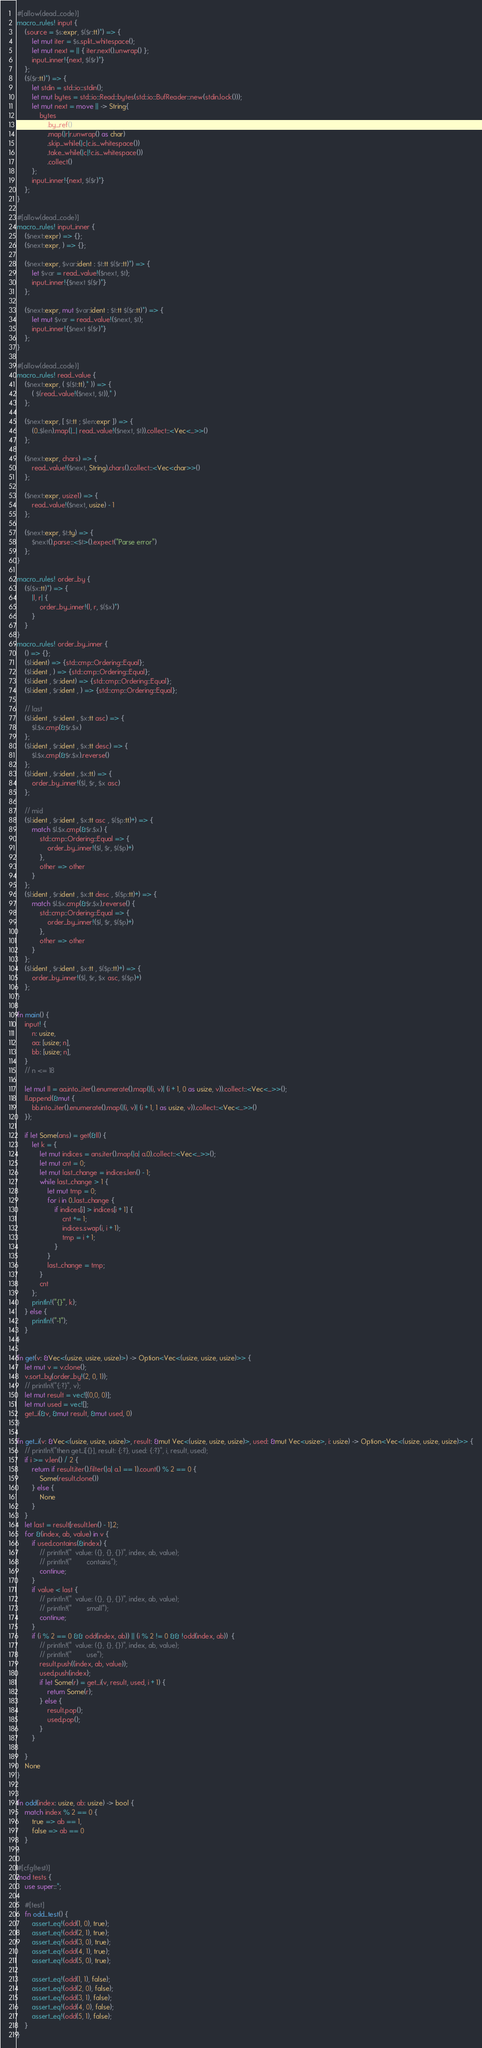Convert code to text. <code><loc_0><loc_0><loc_500><loc_500><_Rust_>#[allow(dead_code)]
macro_rules! input {
    (source = $s:expr, $($r:tt)*) => {
        let mut iter = $s.split_whitespace();
        let mut next = || { iter.next().unwrap() };
        input_inner!{next, $($r)*}
    };
    ($($r:tt)*) => {
        let stdin = std::io::stdin();
        let mut bytes = std::io::Read::bytes(std::io::BufReader::new(stdin.lock()));
        let mut next = move || -> String{
            bytes
                .by_ref()
                .map(|r|r.unwrap() as char)
                .skip_while(|c|c.is_whitespace())
                .take_while(|c|!c.is_whitespace())
                .collect()
        };
        input_inner!{next, $($r)*}
    };
}

#[allow(dead_code)]
macro_rules! input_inner {
    ($next:expr) => {};
    ($next:expr, ) => {};

    ($next:expr, $var:ident : $t:tt $($r:tt)*) => {
        let $var = read_value!($next, $t);
        input_inner!{$next $($r)*}
    };

    ($next:expr, mut $var:ident : $t:tt $($r:tt)*) => {
        let mut $var = read_value!($next, $t);
        input_inner!{$next $($r)*}
    };
}

#[allow(dead_code)]
macro_rules! read_value {
    ($next:expr, ( $($t:tt),* )) => {
        ( $(read_value!($next, $t)),* )
    };

    ($next:expr, [ $t:tt ; $len:expr ]) => {
        (0..$len).map(|_| read_value!($next, $t)).collect::<Vec<_>>()
    };

    ($next:expr, chars) => {
        read_value!($next, String).chars().collect::<Vec<char>>()
    };

    ($next:expr, usize1) => {
        read_value!($next, usize) - 1
    };

    ($next:expr, $t:ty) => {
        $next().parse::<$t>().expect("Parse error")
    };
}

macro_rules! order_by {
    ($($x:tt)*) => {
        |l, r| {
            order_by_inner!(l, r, $($x)*)
        }
    }
}
macro_rules! order_by_inner {
    () => {};
    ($l:ident) => {std::cmp::Ordering::Equal};
    ($l:ident , ) => {std::cmp::Ordering::Equal};
    ($l:ident , $r:ident) => {std::cmp::Ordering::Equal};
    ($l:ident , $r:ident , ) => {std::cmp::Ordering::Equal};

    // last
    ($l:ident , $r:ident , $x:tt asc) => {
        $l.$x.cmp(&$r.$x)
    };
    ($l:ident , $r:ident , $x:tt desc) => {
        $l.$x.cmp(&$r.$x).reverse()
    };
    ($l:ident , $r:ident , $x:tt) => {
        order_by_inner!($l, $r, $x asc)
    };

    // mid
    ($l:ident , $r:ident , $x:tt asc , $($p:tt)+) => {
        match $l.$x.cmp(&$r.$x) {
            std::cmp::Ordering::Equal => {
                order_by_inner!($l, $r, $($p)+)
            },
            other => other
        }
    };
    ($l:ident , $r:ident , $x:tt desc , $($p:tt)+) => {
        match $l.$x.cmp(&$r.$x).reverse() {
            std::cmp::Ordering::Equal => {
                order_by_inner!($l, $r, $($p)+)
            },
            other => other
        }
    };
    ($l:ident , $r:ident , $x:tt , $($p:tt)+) => {
        order_by_inner!($l, $r, $x asc, $($p)+)
    };
}

fn main() {
    input! {
        n: usize,
        aa: [usize; n],
        bb: [usize; n],
    }
    // n <= 18

    let mut ll = aa.into_iter().enumerate().map(|(i, v)| (i + 1, 0 as usize, v)).collect::<Vec<_>>();
    ll.append(&mut {
        bb.into_iter().enumerate().map(|(i, v)| (i + 1, 1 as usize, v)).collect::<Vec<_>>()
    });

    if let Some(ans) = get(&ll) {
        let k = {
            let mut indices = ans.iter().map(|a| a.0).collect::<Vec<_>>();
            let mut cnt = 0;
            let mut last_change = indices.len() - 1;
            while last_change > 1 {
                let mut tmp = 0;
                for i in 0..last_change {
                    if indices[i] > indices[i + 1] {
                        cnt += 1;
                        indices.swap(i, i + 1);
                        tmp = i + 1;
                    }
                }
                last_change = tmp;
            }
            cnt
        };
        println!("{}", k);
    } else {
        println!("-1");
    }
}

fn get(v: &Vec<(usize, usize, usize)>) -> Option<Vec<(usize, usize, usize)>> {
    let mut v = v.clone();
    v.sort_by(order_by!(2, 0, 1));
    // println!("{:?}", v);
    let mut result = vec![(0,0, 0)];
    let mut used = vec![];
    get_i(&v, &mut result, &mut used, 0)
}

fn get_i(v: &Vec<(usize, usize, usize)>, result: &mut Vec<(usize, usize, usize)>, used: &mut Vec<usize>, i: usize) -> Option<Vec<(usize, usize, usize)>> {
    // println!("then get_i[{}], result: {:?}, used: {:?}", i, result, used);
    if i >= v.len() / 2 {
        return if result.iter().filter(|a| a.1 == 1).count() % 2 == 0 {
            Some(result.clone())
        } else {
            None
        }
    }
    let last = result[result.len() - 1].2;
    for &(index, ab, value) in v {
        if used.contains(&index) {
            // println!("  value: ({}, {}, {})", index, ab, value);
            // println!("        contains");
            continue;
        }
        if value < last {
            // println!("  value: ({}, {}, {})", index, ab, value);
            // println!("        small");
            continue;
        }
        if (i % 2 == 0 && odd(index, ab)) || (i % 2 != 0 && !odd(index, ab))  {
            // println!("  value: ({}, {}, {})", index, ab, value);
            // println!("        use");
            result.push((index, ab, value));
            used.push(index);
            if let Some(r) = get_i(v, result, used, i + 1) {
                return Some(r);
            } else {
                result.pop();
                used.pop();
            }
        }

    }
    None
}


fn odd(index: usize, ab: usize) -> bool {
    match index % 2 == 0 {
        true => ab == 1,
        false => ab == 0
    }
}

#[cfg(test)]
mod tests {
    use super::*;

    #[test]
    fn odd_test() {
        assert_eq!(odd(1, 0), true);
        assert_eq!(odd(2, 1), true);
        assert_eq!(odd(3, 0), true);
        assert_eq!(odd(4, 1), true);
        assert_eq!(odd(5, 0), true);

        assert_eq!(odd(1, 1), false);
        assert_eq!(odd(2, 0), false);
        assert_eq!(odd(3, 1), false);
        assert_eq!(odd(4, 0), false);
        assert_eq!(odd(5, 1), false);
    }
}
</code> 